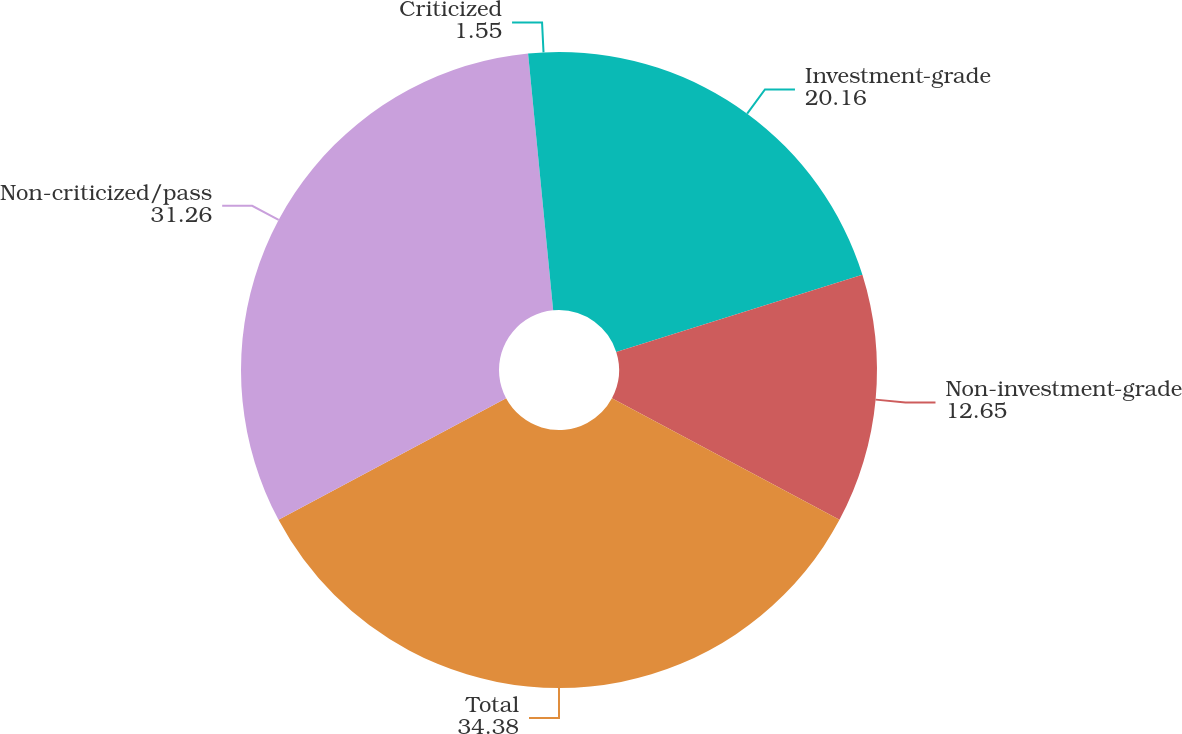<chart> <loc_0><loc_0><loc_500><loc_500><pie_chart><fcel>Investment-grade<fcel>Non-investment-grade<fcel>Total<fcel>Non-criticized/pass<fcel>Criticized<nl><fcel>20.16%<fcel>12.65%<fcel>34.38%<fcel>31.26%<fcel>1.55%<nl></chart> 